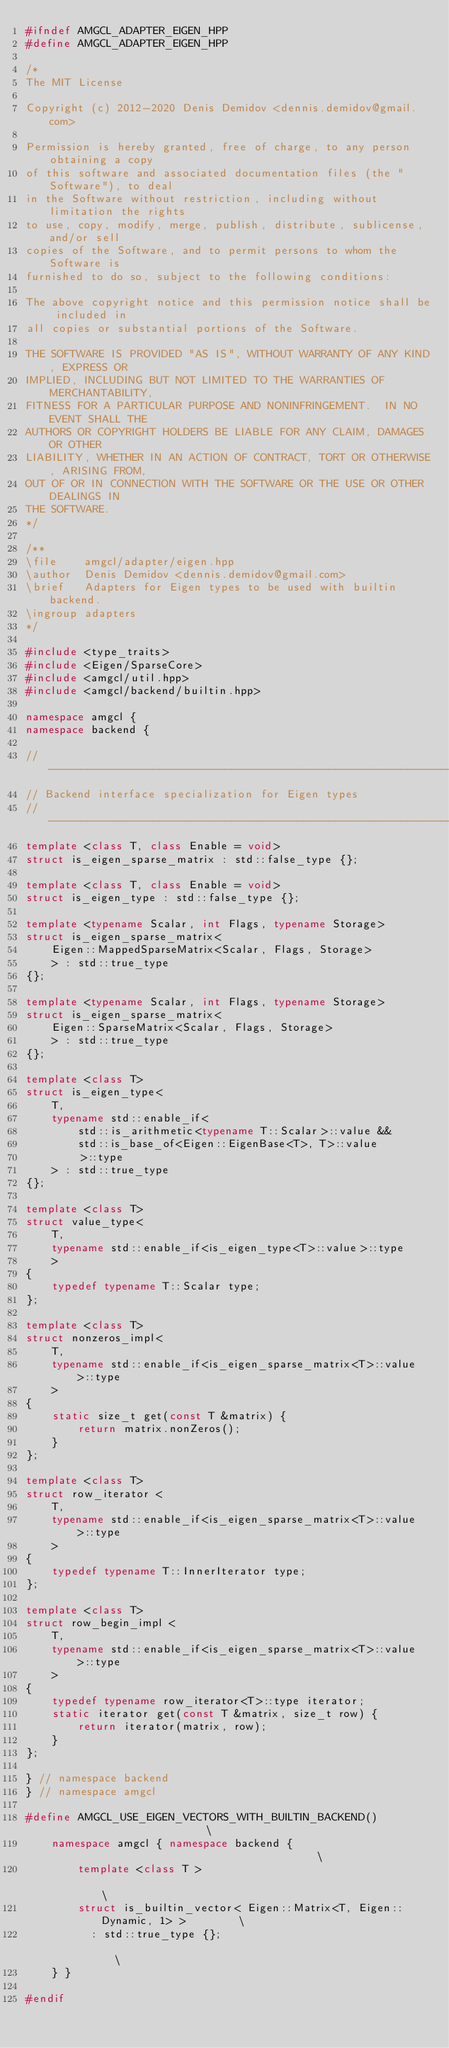<code> <loc_0><loc_0><loc_500><loc_500><_C++_>#ifndef AMGCL_ADAPTER_EIGEN_HPP
#define AMGCL_ADAPTER_EIGEN_HPP

/*
The MIT License

Copyright (c) 2012-2020 Denis Demidov <dennis.demidov@gmail.com>

Permission is hereby granted, free of charge, to any person obtaining a copy
of this software and associated documentation files (the "Software"), to deal
in the Software without restriction, including without limitation the rights
to use, copy, modify, merge, publish, distribute, sublicense, and/or sell
copies of the Software, and to permit persons to whom the Software is
furnished to do so, subject to the following conditions:

The above copyright notice and this permission notice shall be included in
all copies or substantial portions of the Software.

THE SOFTWARE IS PROVIDED "AS IS", WITHOUT WARRANTY OF ANY KIND, EXPRESS OR
IMPLIED, INCLUDING BUT NOT LIMITED TO THE WARRANTIES OF MERCHANTABILITY,
FITNESS FOR A PARTICULAR PURPOSE AND NONINFRINGEMENT.  IN NO EVENT SHALL THE
AUTHORS OR COPYRIGHT HOLDERS BE LIABLE FOR ANY CLAIM, DAMAGES OR OTHER
LIABILITY, WHETHER IN AN ACTION OF CONTRACT, TORT OR OTHERWISE, ARISING FROM,
OUT OF OR IN CONNECTION WITH THE SOFTWARE OR THE USE OR OTHER DEALINGS IN
THE SOFTWARE.
*/

/**
\file    amgcl/adapter/eigen.hpp
\author  Denis Demidov <dennis.demidov@gmail.com>
\brief   Adapters for Eigen types to be used with builtin backend.
\ingroup adapters
*/

#include <type_traits>
#include <Eigen/SparseCore>
#include <amgcl/util.hpp>
#include <amgcl/backend/builtin.hpp>

namespace amgcl {
namespace backend {

//---------------------------------------------------------------------------
// Backend interface specialization for Eigen types
//---------------------------------------------------------------------------
template <class T, class Enable = void>
struct is_eigen_sparse_matrix : std::false_type {};

template <class T, class Enable = void>
struct is_eigen_type : std::false_type {};

template <typename Scalar, int Flags, typename Storage>
struct is_eigen_sparse_matrix<
    Eigen::MappedSparseMatrix<Scalar, Flags, Storage>
    > : std::true_type
{};

template <typename Scalar, int Flags, typename Storage>
struct is_eigen_sparse_matrix<
    Eigen::SparseMatrix<Scalar, Flags, Storage>
    > : std::true_type
{};

template <class T>
struct is_eigen_type<
    T,
    typename std::enable_if<
        std::is_arithmetic<typename T::Scalar>::value &&
        std::is_base_of<Eigen::EigenBase<T>, T>::value
        >::type
    > : std::true_type
{};

template <class T>
struct value_type<
    T,
    typename std::enable_if<is_eigen_type<T>::value>::type
    >
{
    typedef typename T::Scalar type;
};

template <class T>
struct nonzeros_impl<
    T,
    typename std::enable_if<is_eigen_sparse_matrix<T>::value>::type
    >
{
    static size_t get(const T &matrix) {
        return matrix.nonZeros();
    }
};

template <class T>
struct row_iterator <
    T,
    typename std::enable_if<is_eigen_sparse_matrix<T>::value>::type
    >
{
    typedef typename T::InnerIterator type;
};

template <class T>
struct row_begin_impl <
    T,
    typename std::enable_if<is_eigen_sparse_matrix<T>::value>::type
    >
{
    typedef typename row_iterator<T>::type iterator;
    static iterator get(const T &matrix, size_t row) {
        return iterator(matrix, row);
    }
};

} // namespace backend
} // namespace amgcl

#define AMGCL_USE_EIGEN_VECTORS_WITH_BUILTIN_BACKEND()                         \
    namespace amgcl { namespace backend {                                      \
        template <class T >                                                    \
        struct is_builtin_vector< Eigen::Matrix<T, Eigen::Dynamic, 1> >        \
          : std::true_type {};                                                 \
    } }

#endif
</code> 